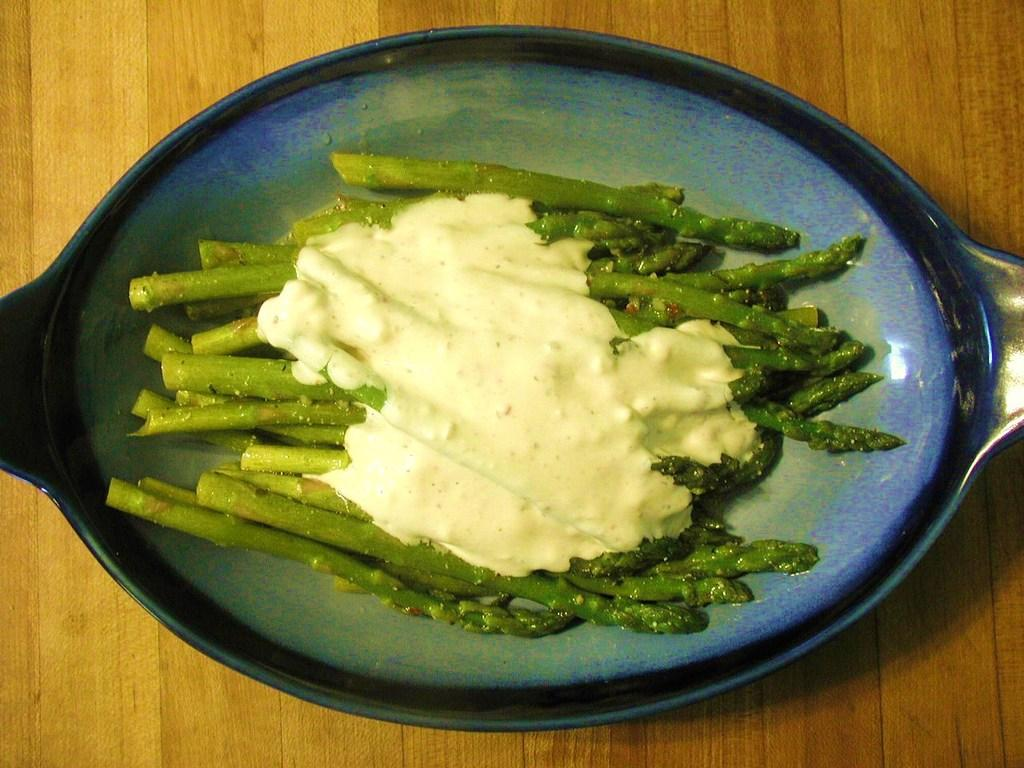What is located on the wooden surface in the image? There is a bowl on the wooden surface in the image. What is inside the bowl? There are food items in the bowl. How many hens can be seen in the image? There are no hens present in the image. What time of day is depicted in the image? The time of day is not mentioned or depicted in the image. 